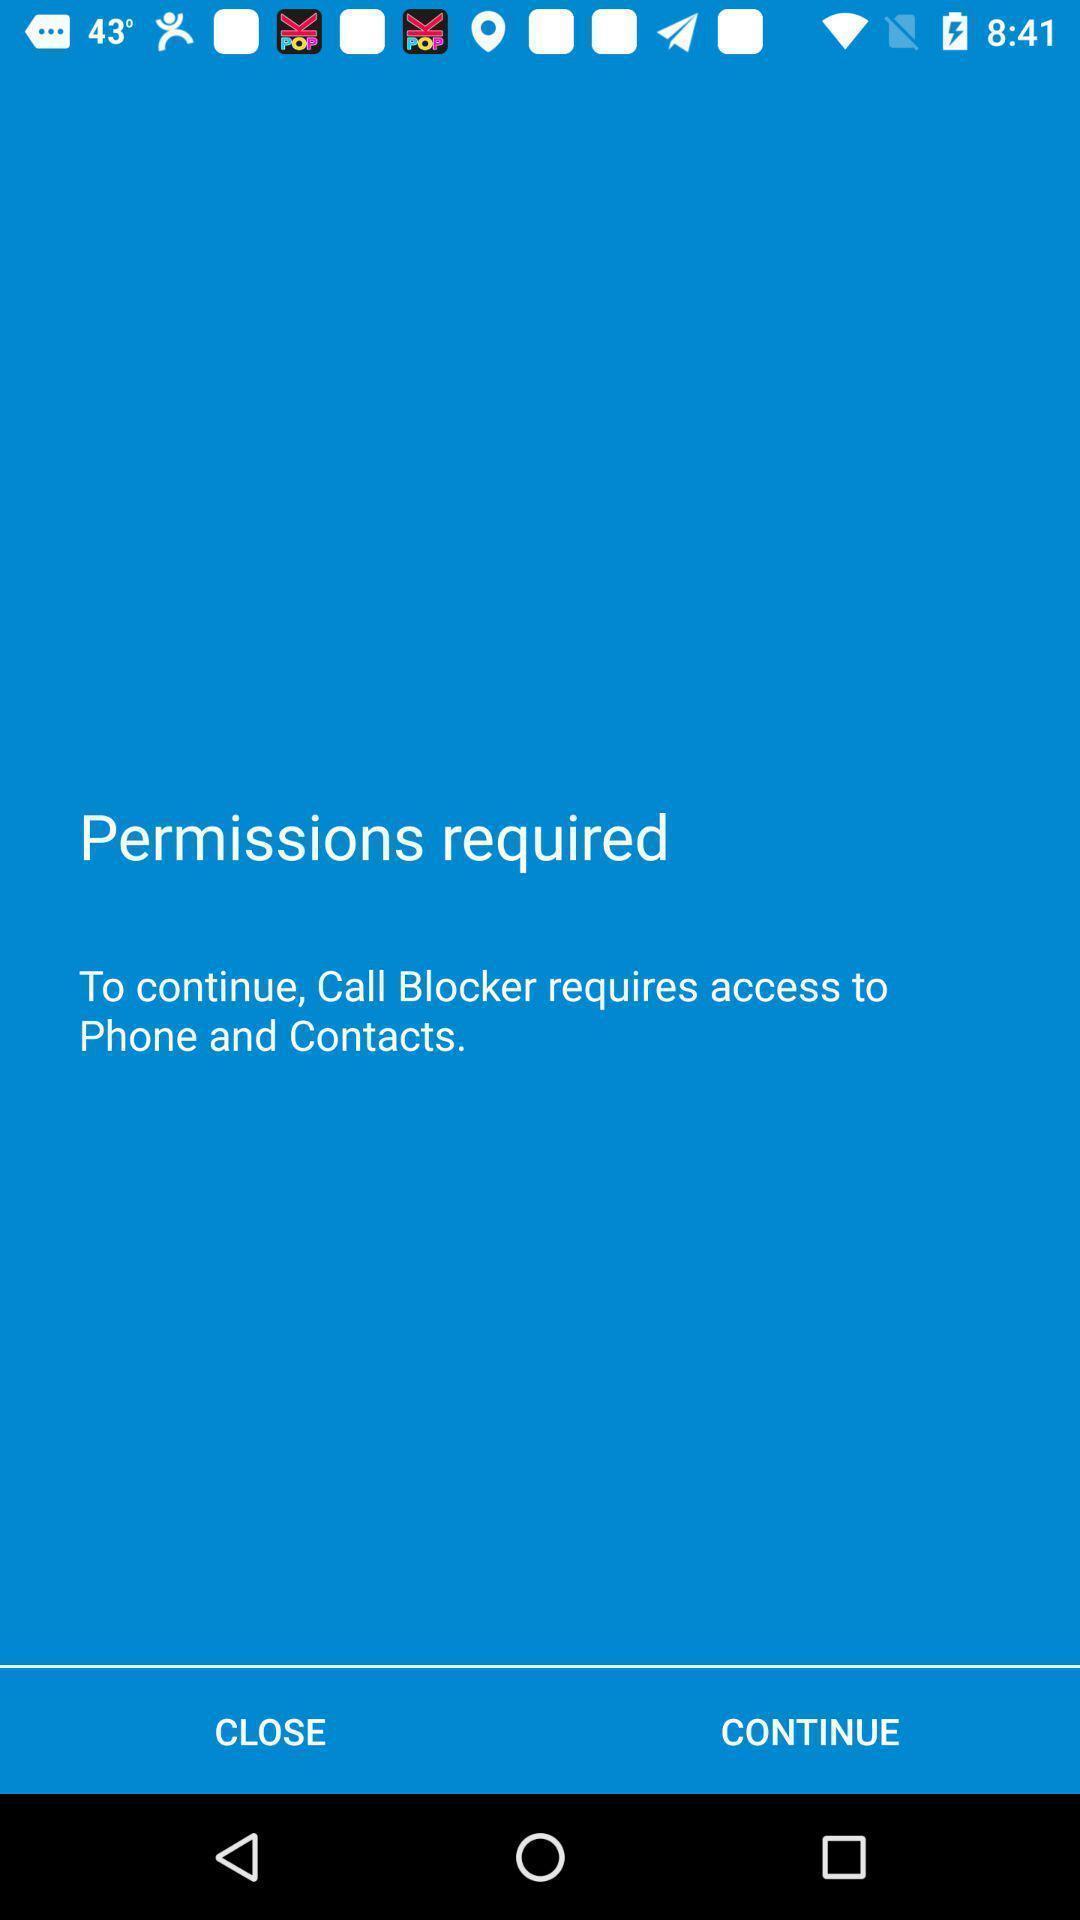Provide a description of this screenshot. Screen showing permission required option. 